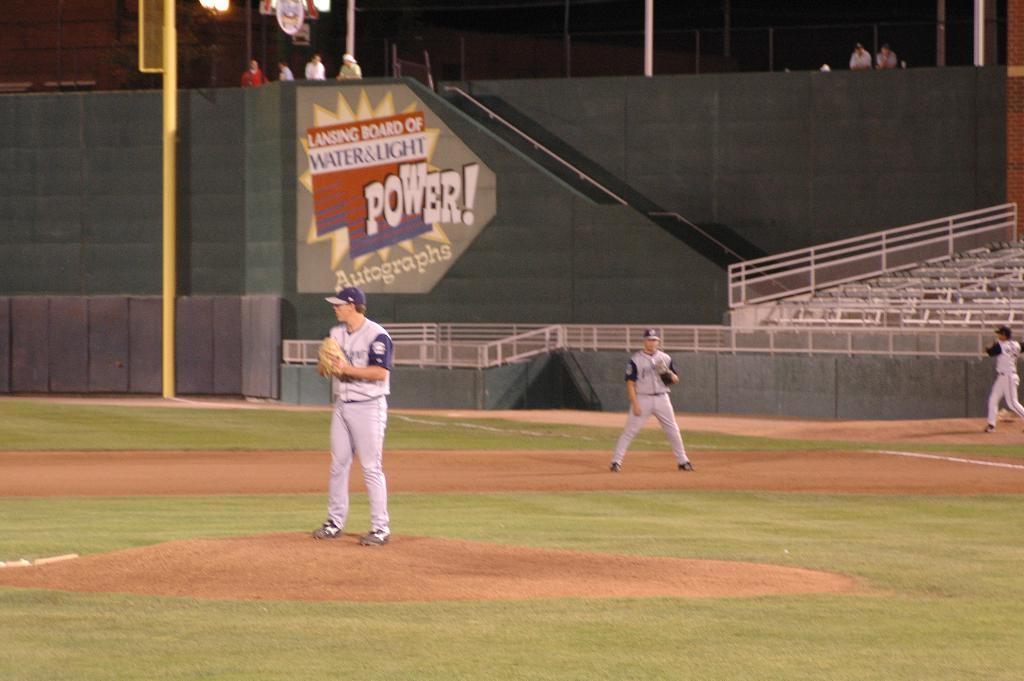<image>
Offer a succinct explanation of the picture presented. The Power which is written on the wall in the outfield 